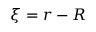Convert formula to latex. <formula><loc_0><loc_0><loc_500><loc_500>\xi = r - R</formula> 